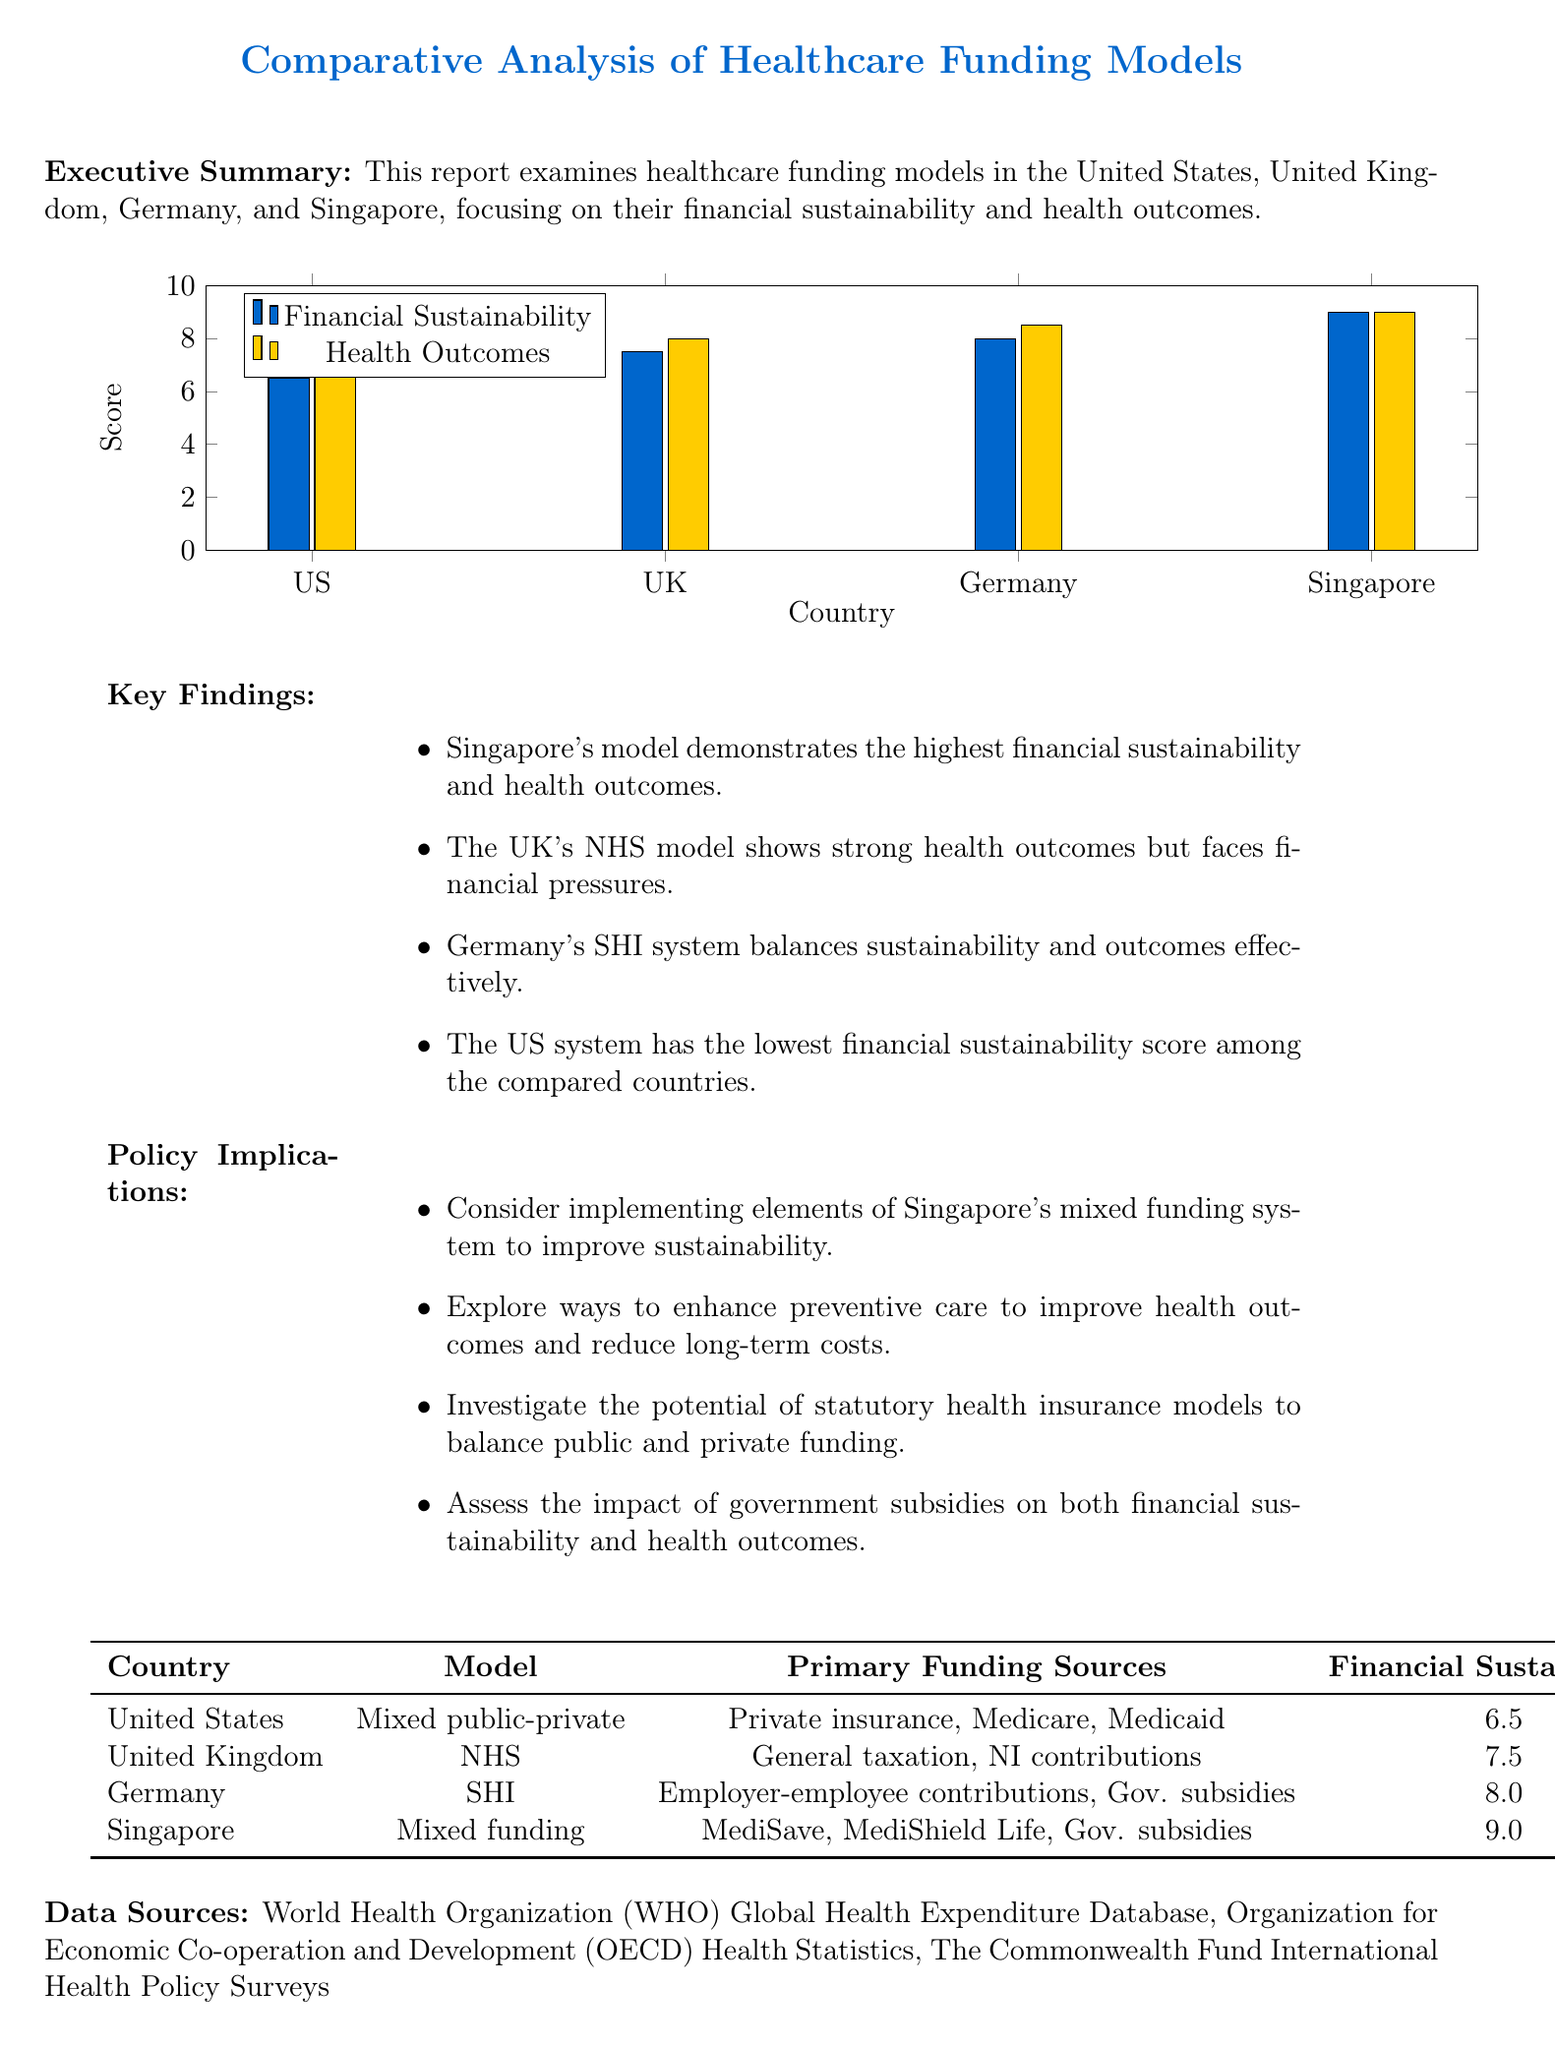what is the title of the report? The title of the report is stated at the beginning of the document.
Answer: Comparative Analysis of Healthcare Funding Models: Financial Sustainability and Outcomes which country has the highest financial sustainability score? The report provides scores for financial sustainability for each country, with Singapore having the highest score.
Answer: Singapore what is the primary funding source for the UK’s NHS model? This information is listed under the funding models section in the document, highlighting key funding sources for each country.
Answer: General taxation, National Insurance contributions what was the health outcome score for the United States? The health outcome score for the US is included in the summary table of the funding models.
Answer: 7.0 which funding model is used in Germany? The specific funding model for Germany is noted in the funding models section of the report.
Answer: Statutory Health Insurance (SHI) what policy implication suggests enhancing preventive care? This is one of the proposed policy implications that is listed clearly in the document.
Answer: Explore ways to enhance preventive care to improve health outcomes and reduce long-term costs how many countries are compared in the report? The number of countries included in the analysis is specified in the executive summary section.
Answer: Four 